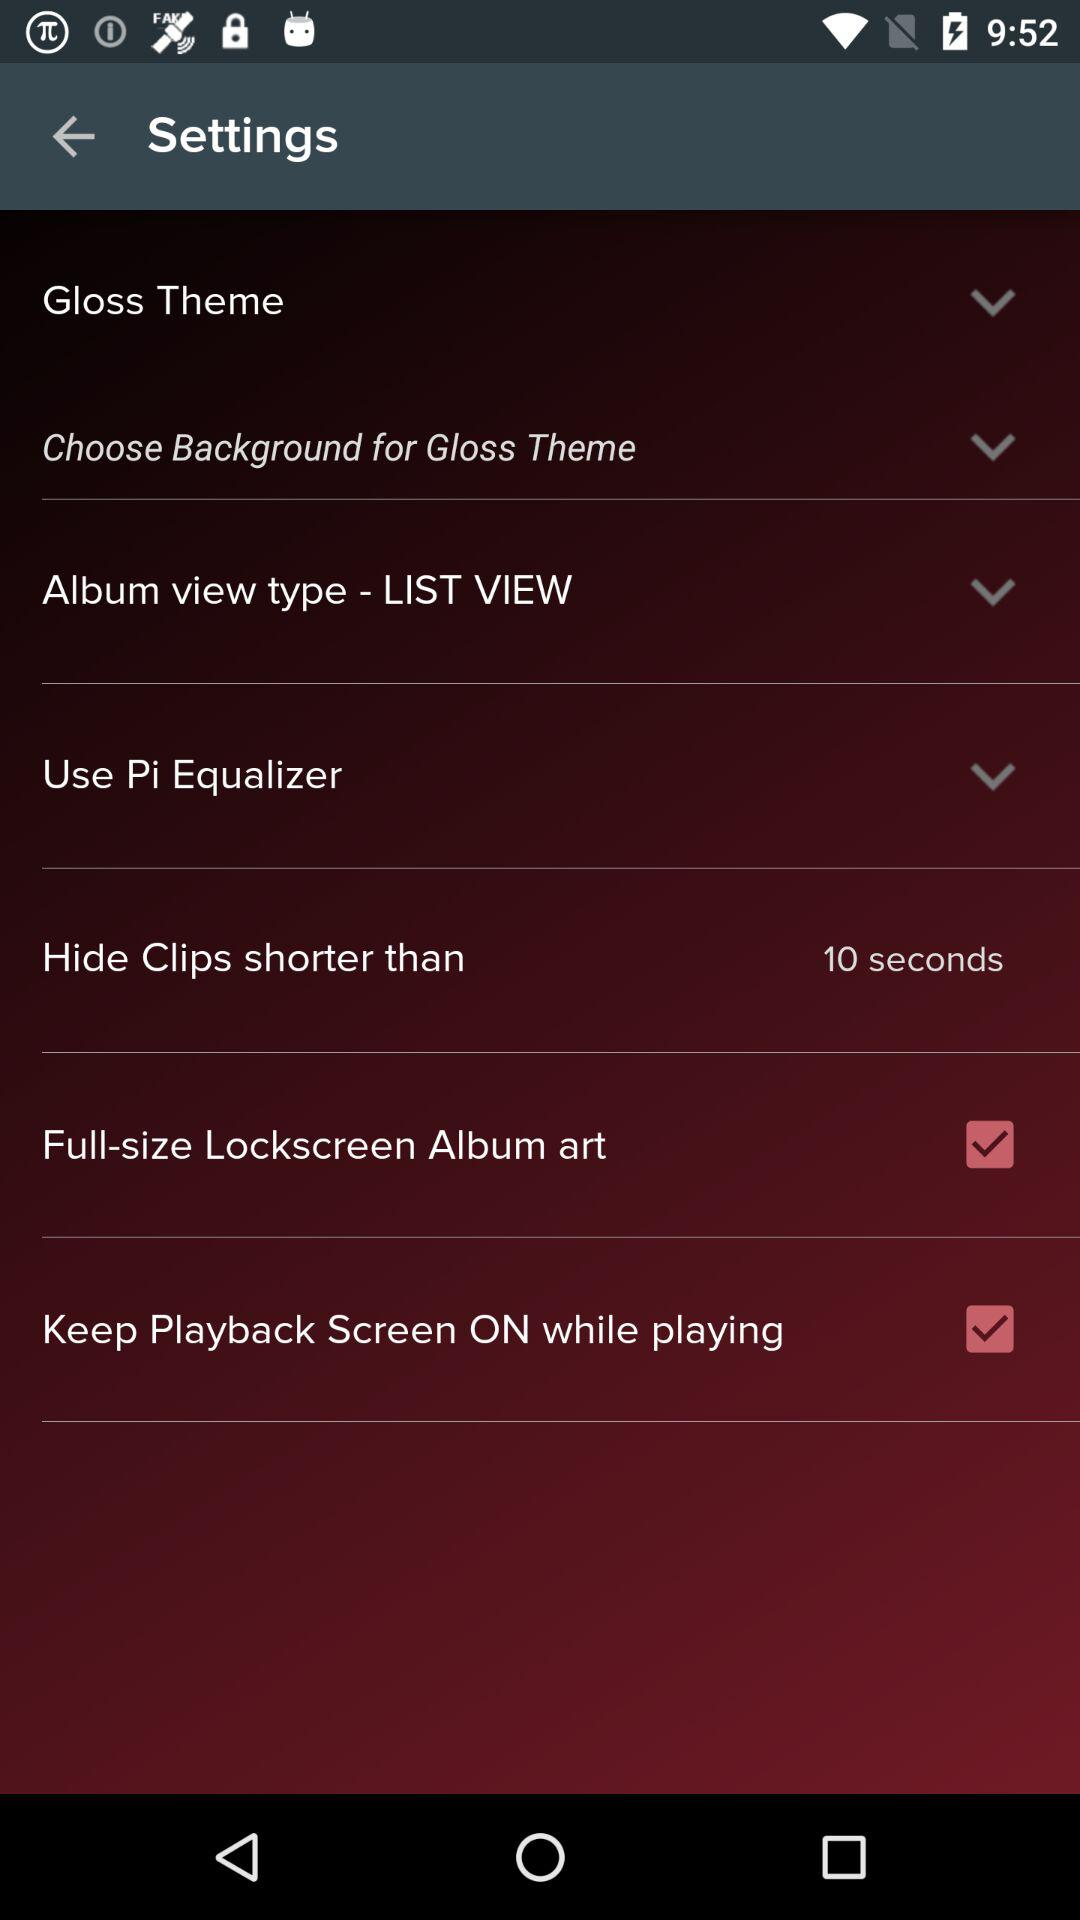What is the status of "Full-size Lockscreen Album art"? The status of "Full-size Lockscreen Album art" is "on". 